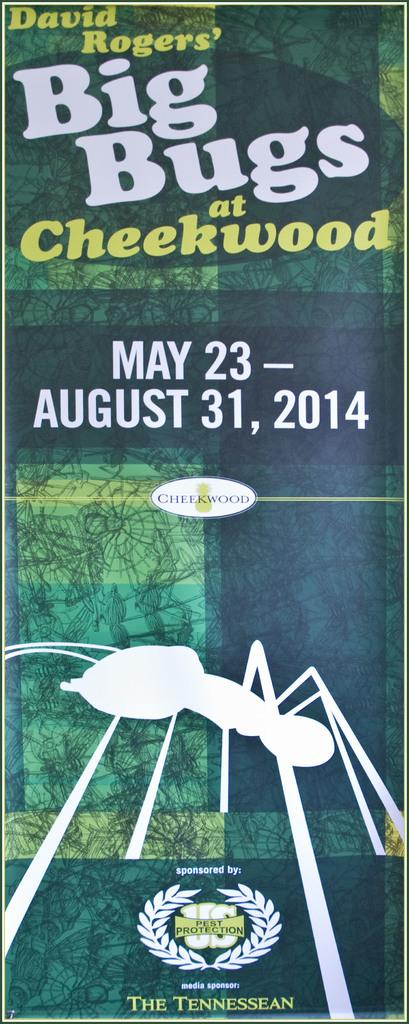What is the color of the poster in the image? The poster is green. What information is included on the poster? The poster contains text and a date. What image is depicted on the poster? There is a picture of an ant on the poster. What time of day is the swim taking place in the image? There is no swim or any indication of a specific time of day in the image; it features a green poster with text, a date, and a picture of an ant. 